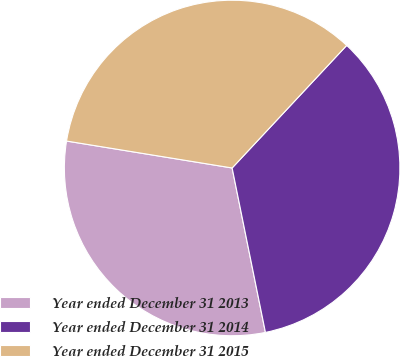Convert chart. <chart><loc_0><loc_0><loc_500><loc_500><pie_chart><fcel>Year ended December 31 2013<fcel>Year ended December 31 2014<fcel>Year ended December 31 2015<nl><fcel>30.75%<fcel>34.86%<fcel>34.4%<nl></chart> 